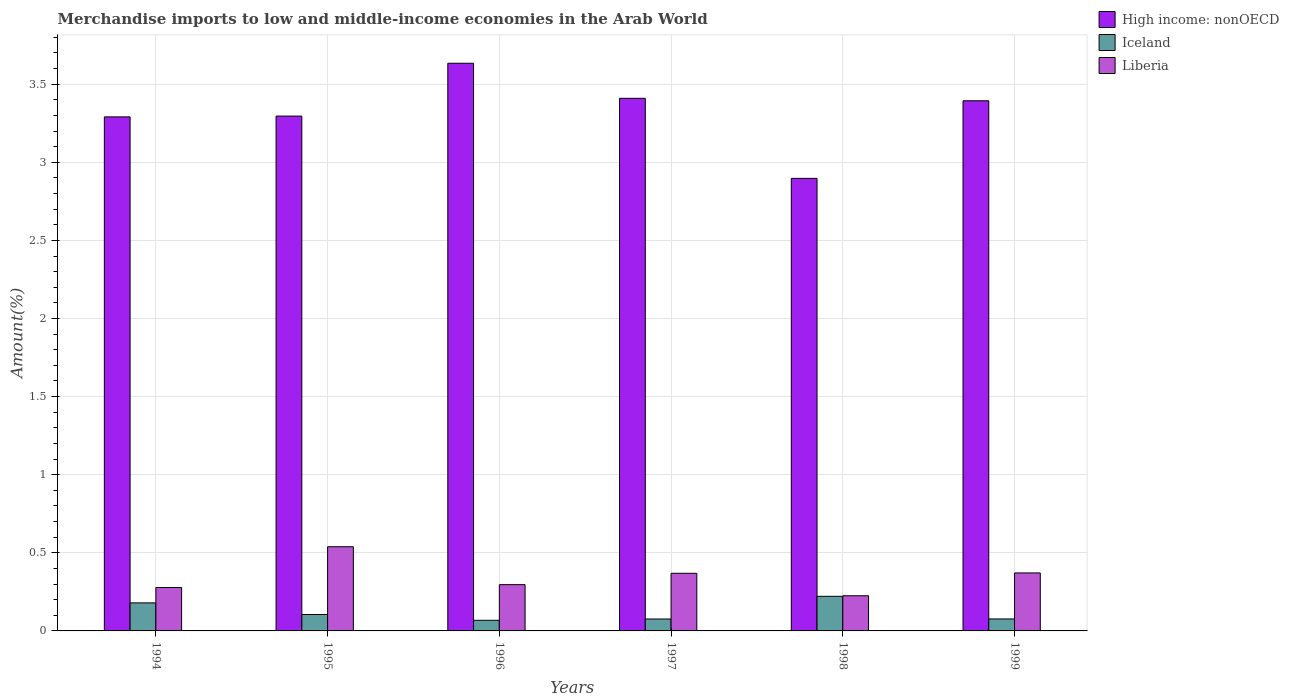How many different coloured bars are there?
Provide a short and direct response. 3. Are the number of bars per tick equal to the number of legend labels?
Provide a short and direct response. Yes. What is the label of the 6th group of bars from the left?
Provide a succinct answer. 1999. In how many cases, is the number of bars for a given year not equal to the number of legend labels?
Make the answer very short. 0. What is the percentage of amount earned from merchandise imports in Liberia in 1995?
Offer a very short reply. 0.54. Across all years, what is the maximum percentage of amount earned from merchandise imports in High income: nonOECD?
Give a very brief answer. 3.63. Across all years, what is the minimum percentage of amount earned from merchandise imports in Liberia?
Your answer should be very brief. 0.23. In which year was the percentage of amount earned from merchandise imports in High income: nonOECD minimum?
Keep it short and to the point. 1998. What is the total percentage of amount earned from merchandise imports in High income: nonOECD in the graph?
Keep it short and to the point. 19.92. What is the difference between the percentage of amount earned from merchandise imports in High income: nonOECD in 1995 and that in 1996?
Keep it short and to the point. -0.34. What is the difference between the percentage of amount earned from merchandise imports in Liberia in 1996 and the percentage of amount earned from merchandise imports in High income: nonOECD in 1994?
Offer a terse response. -2.99. What is the average percentage of amount earned from merchandise imports in High income: nonOECD per year?
Make the answer very short. 3.32. In the year 1999, what is the difference between the percentage of amount earned from merchandise imports in Iceland and percentage of amount earned from merchandise imports in High income: nonOECD?
Make the answer very short. -3.32. In how many years, is the percentage of amount earned from merchandise imports in Liberia greater than 1.4 %?
Offer a very short reply. 0. What is the ratio of the percentage of amount earned from merchandise imports in Liberia in 1994 to that in 1995?
Ensure brevity in your answer.  0.52. What is the difference between the highest and the second highest percentage of amount earned from merchandise imports in Iceland?
Keep it short and to the point. 0.04. What is the difference between the highest and the lowest percentage of amount earned from merchandise imports in High income: nonOECD?
Offer a terse response. 0.74. What does the 1st bar from the left in 1997 represents?
Offer a very short reply. High income: nonOECD. What does the 3rd bar from the right in 1999 represents?
Make the answer very short. High income: nonOECD. Is it the case that in every year, the sum of the percentage of amount earned from merchandise imports in Liberia and percentage of amount earned from merchandise imports in Iceland is greater than the percentage of amount earned from merchandise imports in High income: nonOECD?
Make the answer very short. No. How many bars are there?
Offer a very short reply. 18. Are all the bars in the graph horizontal?
Make the answer very short. No. How many years are there in the graph?
Provide a succinct answer. 6. Does the graph contain grids?
Give a very brief answer. Yes. How many legend labels are there?
Your answer should be compact. 3. What is the title of the graph?
Give a very brief answer. Merchandise imports to low and middle-income economies in the Arab World. What is the label or title of the X-axis?
Ensure brevity in your answer.  Years. What is the label or title of the Y-axis?
Offer a terse response. Amount(%). What is the Amount(%) in High income: nonOECD in 1994?
Make the answer very short. 3.29. What is the Amount(%) of Iceland in 1994?
Ensure brevity in your answer.  0.18. What is the Amount(%) of Liberia in 1994?
Provide a short and direct response. 0.28. What is the Amount(%) in High income: nonOECD in 1995?
Keep it short and to the point. 3.3. What is the Amount(%) of Iceland in 1995?
Provide a short and direct response. 0.11. What is the Amount(%) in Liberia in 1995?
Your answer should be very brief. 0.54. What is the Amount(%) in High income: nonOECD in 1996?
Offer a terse response. 3.63. What is the Amount(%) of Iceland in 1996?
Provide a short and direct response. 0.07. What is the Amount(%) in Liberia in 1996?
Ensure brevity in your answer.  0.3. What is the Amount(%) of High income: nonOECD in 1997?
Your response must be concise. 3.41. What is the Amount(%) in Iceland in 1997?
Offer a terse response. 0.08. What is the Amount(%) in Liberia in 1997?
Keep it short and to the point. 0.37. What is the Amount(%) in High income: nonOECD in 1998?
Offer a very short reply. 2.9. What is the Amount(%) in Iceland in 1998?
Make the answer very short. 0.22. What is the Amount(%) of Liberia in 1998?
Your response must be concise. 0.23. What is the Amount(%) of High income: nonOECD in 1999?
Provide a short and direct response. 3.39. What is the Amount(%) of Iceland in 1999?
Your answer should be compact. 0.08. What is the Amount(%) in Liberia in 1999?
Offer a very short reply. 0.37. Across all years, what is the maximum Amount(%) in High income: nonOECD?
Offer a very short reply. 3.63. Across all years, what is the maximum Amount(%) of Iceland?
Provide a short and direct response. 0.22. Across all years, what is the maximum Amount(%) in Liberia?
Make the answer very short. 0.54. Across all years, what is the minimum Amount(%) in High income: nonOECD?
Offer a terse response. 2.9. Across all years, what is the minimum Amount(%) of Iceland?
Provide a short and direct response. 0.07. Across all years, what is the minimum Amount(%) of Liberia?
Offer a very short reply. 0.23. What is the total Amount(%) in High income: nonOECD in the graph?
Ensure brevity in your answer.  19.92. What is the total Amount(%) of Iceland in the graph?
Keep it short and to the point. 0.73. What is the total Amount(%) of Liberia in the graph?
Provide a short and direct response. 2.08. What is the difference between the Amount(%) in High income: nonOECD in 1994 and that in 1995?
Ensure brevity in your answer.  -0.01. What is the difference between the Amount(%) in Iceland in 1994 and that in 1995?
Keep it short and to the point. 0.07. What is the difference between the Amount(%) of Liberia in 1994 and that in 1995?
Your answer should be compact. -0.26. What is the difference between the Amount(%) of High income: nonOECD in 1994 and that in 1996?
Make the answer very short. -0.34. What is the difference between the Amount(%) of Iceland in 1994 and that in 1996?
Offer a very short reply. 0.11. What is the difference between the Amount(%) of Liberia in 1994 and that in 1996?
Give a very brief answer. -0.02. What is the difference between the Amount(%) in High income: nonOECD in 1994 and that in 1997?
Your answer should be compact. -0.12. What is the difference between the Amount(%) of Iceland in 1994 and that in 1997?
Offer a terse response. 0.1. What is the difference between the Amount(%) of Liberia in 1994 and that in 1997?
Provide a short and direct response. -0.09. What is the difference between the Amount(%) of High income: nonOECD in 1994 and that in 1998?
Provide a succinct answer. 0.39. What is the difference between the Amount(%) in Iceland in 1994 and that in 1998?
Provide a succinct answer. -0.04. What is the difference between the Amount(%) of Liberia in 1994 and that in 1998?
Your answer should be very brief. 0.05. What is the difference between the Amount(%) in High income: nonOECD in 1994 and that in 1999?
Your answer should be compact. -0.1. What is the difference between the Amount(%) of Iceland in 1994 and that in 1999?
Offer a terse response. 0.1. What is the difference between the Amount(%) of Liberia in 1994 and that in 1999?
Your response must be concise. -0.09. What is the difference between the Amount(%) of High income: nonOECD in 1995 and that in 1996?
Make the answer very short. -0.34. What is the difference between the Amount(%) of Iceland in 1995 and that in 1996?
Provide a succinct answer. 0.04. What is the difference between the Amount(%) in Liberia in 1995 and that in 1996?
Your response must be concise. 0.24. What is the difference between the Amount(%) in High income: nonOECD in 1995 and that in 1997?
Ensure brevity in your answer.  -0.11. What is the difference between the Amount(%) in Iceland in 1995 and that in 1997?
Make the answer very short. 0.03. What is the difference between the Amount(%) of Liberia in 1995 and that in 1997?
Provide a succinct answer. 0.17. What is the difference between the Amount(%) of High income: nonOECD in 1995 and that in 1998?
Provide a succinct answer. 0.4. What is the difference between the Amount(%) of Iceland in 1995 and that in 1998?
Your answer should be very brief. -0.12. What is the difference between the Amount(%) of Liberia in 1995 and that in 1998?
Your answer should be very brief. 0.31. What is the difference between the Amount(%) of High income: nonOECD in 1995 and that in 1999?
Ensure brevity in your answer.  -0.1. What is the difference between the Amount(%) of Iceland in 1995 and that in 1999?
Your answer should be very brief. 0.03. What is the difference between the Amount(%) of Liberia in 1995 and that in 1999?
Provide a short and direct response. 0.17. What is the difference between the Amount(%) of High income: nonOECD in 1996 and that in 1997?
Offer a terse response. 0.22. What is the difference between the Amount(%) in Iceland in 1996 and that in 1997?
Your response must be concise. -0.01. What is the difference between the Amount(%) in Liberia in 1996 and that in 1997?
Your answer should be very brief. -0.07. What is the difference between the Amount(%) of High income: nonOECD in 1996 and that in 1998?
Offer a terse response. 0.74. What is the difference between the Amount(%) of Iceland in 1996 and that in 1998?
Give a very brief answer. -0.15. What is the difference between the Amount(%) of Liberia in 1996 and that in 1998?
Your answer should be very brief. 0.07. What is the difference between the Amount(%) of High income: nonOECD in 1996 and that in 1999?
Your response must be concise. 0.24. What is the difference between the Amount(%) of Iceland in 1996 and that in 1999?
Provide a short and direct response. -0.01. What is the difference between the Amount(%) in Liberia in 1996 and that in 1999?
Ensure brevity in your answer.  -0.08. What is the difference between the Amount(%) of High income: nonOECD in 1997 and that in 1998?
Your answer should be very brief. 0.51. What is the difference between the Amount(%) in Iceland in 1997 and that in 1998?
Make the answer very short. -0.15. What is the difference between the Amount(%) in Liberia in 1997 and that in 1998?
Your answer should be compact. 0.14. What is the difference between the Amount(%) in High income: nonOECD in 1997 and that in 1999?
Offer a very short reply. 0.02. What is the difference between the Amount(%) of Iceland in 1997 and that in 1999?
Your answer should be compact. -0. What is the difference between the Amount(%) in Liberia in 1997 and that in 1999?
Ensure brevity in your answer.  -0. What is the difference between the Amount(%) of High income: nonOECD in 1998 and that in 1999?
Offer a terse response. -0.5. What is the difference between the Amount(%) in Iceland in 1998 and that in 1999?
Your answer should be compact. 0.14. What is the difference between the Amount(%) in Liberia in 1998 and that in 1999?
Ensure brevity in your answer.  -0.15. What is the difference between the Amount(%) in High income: nonOECD in 1994 and the Amount(%) in Iceland in 1995?
Your answer should be compact. 3.19. What is the difference between the Amount(%) of High income: nonOECD in 1994 and the Amount(%) of Liberia in 1995?
Keep it short and to the point. 2.75. What is the difference between the Amount(%) in Iceland in 1994 and the Amount(%) in Liberia in 1995?
Your answer should be compact. -0.36. What is the difference between the Amount(%) of High income: nonOECD in 1994 and the Amount(%) of Iceland in 1996?
Offer a very short reply. 3.22. What is the difference between the Amount(%) of High income: nonOECD in 1994 and the Amount(%) of Liberia in 1996?
Make the answer very short. 2.99. What is the difference between the Amount(%) of Iceland in 1994 and the Amount(%) of Liberia in 1996?
Provide a succinct answer. -0.12. What is the difference between the Amount(%) in High income: nonOECD in 1994 and the Amount(%) in Iceland in 1997?
Provide a short and direct response. 3.21. What is the difference between the Amount(%) in High income: nonOECD in 1994 and the Amount(%) in Liberia in 1997?
Ensure brevity in your answer.  2.92. What is the difference between the Amount(%) in Iceland in 1994 and the Amount(%) in Liberia in 1997?
Ensure brevity in your answer.  -0.19. What is the difference between the Amount(%) of High income: nonOECD in 1994 and the Amount(%) of Iceland in 1998?
Ensure brevity in your answer.  3.07. What is the difference between the Amount(%) of High income: nonOECD in 1994 and the Amount(%) of Liberia in 1998?
Give a very brief answer. 3.07. What is the difference between the Amount(%) in Iceland in 1994 and the Amount(%) in Liberia in 1998?
Your response must be concise. -0.05. What is the difference between the Amount(%) in High income: nonOECD in 1994 and the Amount(%) in Iceland in 1999?
Ensure brevity in your answer.  3.21. What is the difference between the Amount(%) in High income: nonOECD in 1994 and the Amount(%) in Liberia in 1999?
Keep it short and to the point. 2.92. What is the difference between the Amount(%) of Iceland in 1994 and the Amount(%) of Liberia in 1999?
Keep it short and to the point. -0.19. What is the difference between the Amount(%) in High income: nonOECD in 1995 and the Amount(%) in Iceland in 1996?
Give a very brief answer. 3.23. What is the difference between the Amount(%) in High income: nonOECD in 1995 and the Amount(%) in Liberia in 1996?
Your response must be concise. 3. What is the difference between the Amount(%) in Iceland in 1995 and the Amount(%) in Liberia in 1996?
Make the answer very short. -0.19. What is the difference between the Amount(%) of High income: nonOECD in 1995 and the Amount(%) of Iceland in 1997?
Give a very brief answer. 3.22. What is the difference between the Amount(%) in High income: nonOECD in 1995 and the Amount(%) in Liberia in 1997?
Ensure brevity in your answer.  2.93. What is the difference between the Amount(%) of Iceland in 1995 and the Amount(%) of Liberia in 1997?
Keep it short and to the point. -0.26. What is the difference between the Amount(%) in High income: nonOECD in 1995 and the Amount(%) in Iceland in 1998?
Your answer should be compact. 3.07. What is the difference between the Amount(%) of High income: nonOECD in 1995 and the Amount(%) of Liberia in 1998?
Give a very brief answer. 3.07. What is the difference between the Amount(%) of Iceland in 1995 and the Amount(%) of Liberia in 1998?
Your answer should be very brief. -0.12. What is the difference between the Amount(%) of High income: nonOECD in 1995 and the Amount(%) of Iceland in 1999?
Provide a short and direct response. 3.22. What is the difference between the Amount(%) of High income: nonOECD in 1995 and the Amount(%) of Liberia in 1999?
Ensure brevity in your answer.  2.92. What is the difference between the Amount(%) of Iceland in 1995 and the Amount(%) of Liberia in 1999?
Make the answer very short. -0.27. What is the difference between the Amount(%) in High income: nonOECD in 1996 and the Amount(%) in Iceland in 1997?
Provide a succinct answer. 3.56. What is the difference between the Amount(%) in High income: nonOECD in 1996 and the Amount(%) in Liberia in 1997?
Ensure brevity in your answer.  3.27. What is the difference between the Amount(%) in Iceland in 1996 and the Amount(%) in Liberia in 1997?
Offer a very short reply. -0.3. What is the difference between the Amount(%) of High income: nonOECD in 1996 and the Amount(%) of Iceland in 1998?
Provide a short and direct response. 3.41. What is the difference between the Amount(%) of High income: nonOECD in 1996 and the Amount(%) of Liberia in 1998?
Offer a very short reply. 3.41. What is the difference between the Amount(%) in Iceland in 1996 and the Amount(%) in Liberia in 1998?
Ensure brevity in your answer.  -0.16. What is the difference between the Amount(%) in High income: nonOECD in 1996 and the Amount(%) in Iceland in 1999?
Provide a succinct answer. 3.56. What is the difference between the Amount(%) of High income: nonOECD in 1996 and the Amount(%) of Liberia in 1999?
Your answer should be compact. 3.26. What is the difference between the Amount(%) of Iceland in 1996 and the Amount(%) of Liberia in 1999?
Make the answer very short. -0.3. What is the difference between the Amount(%) in High income: nonOECD in 1997 and the Amount(%) in Iceland in 1998?
Make the answer very short. 3.19. What is the difference between the Amount(%) of High income: nonOECD in 1997 and the Amount(%) of Liberia in 1998?
Provide a succinct answer. 3.18. What is the difference between the Amount(%) of Iceland in 1997 and the Amount(%) of Liberia in 1998?
Your answer should be very brief. -0.15. What is the difference between the Amount(%) in High income: nonOECD in 1997 and the Amount(%) in Iceland in 1999?
Provide a succinct answer. 3.33. What is the difference between the Amount(%) in High income: nonOECD in 1997 and the Amount(%) in Liberia in 1999?
Make the answer very short. 3.04. What is the difference between the Amount(%) of Iceland in 1997 and the Amount(%) of Liberia in 1999?
Offer a very short reply. -0.29. What is the difference between the Amount(%) of High income: nonOECD in 1998 and the Amount(%) of Iceland in 1999?
Give a very brief answer. 2.82. What is the difference between the Amount(%) of High income: nonOECD in 1998 and the Amount(%) of Liberia in 1999?
Your response must be concise. 2.53. What is the difference between the Amount(%) of Iceland in 1998 and the Amount(%) of Liberia in 1999?
Your answer should be compact. -0.15. What is the average Amount(%) in High income: nonOECD per year?
Provide a succinct answer. 3.32. What is the average Amount(%) of Iceland per year?
Provide a short and direct response. 0.12. What is the average Amount(%) of Liberia per year?
Keep it short and to the point. 0.35. In the year 1994, what is the difference between the Amount(%) in High income: nonOECD and Amount(%) in Iceland?
Give a very brief answer. 3.11. In the year 1994, what is the difference between the Amount(%) of High income: nonOECD and Amount(%) of Liberia?
Your response must be concise. 3.01. In the year 1994, what is the difference between the Amount(%) of Iceland and Amount(%) of Liberia?
Provide a short and direct response. -0.1. In the year 1995, what is the difference between the Amount(%) in High income: nonOECD and Amount(%) in Iceland?
Make the answer very short. 3.19. In the year 1995, what is the difference between the Amount(%) in High income: nonOECD and Amount(%) in Liberia?
Provide a succinct answer. 2.76. In the year 1995, what is the difference between the Amount(%) of Iceland and Amount(%) of Liberia?
Ensure brevity in your answer.  -0.43. In the year 1996, what is the difference between the Amount(%) of High income: nonOECD and Amount(%) of Iceland?
Your answer should be compact. 3.57. In the year 1996, what is the difference between the Amount(%) of High income: nonOECD and Amount(%) of Liberia?
Make the answer very short. 3.34. In the year 1996, what is the difference between the Amount(%) of Iceland and Amount(%) of Liberia?
Make the answer very short. -0.23. In the year 1997, what is the difference between the Amount(%) in High income: nonOECD and Amount(%) in Iceland?
Your answer should be compact. 3.33. In the year 1997, what is the difference between the Amount(%) in High income: nonOECD and Amount(%) in Liberia?
Your answer should be very brief. 3.04. In the year 1997, what is the difference between the Amount(%) of Iceland and Amount(%) of Liberia?
Ensure brevity in your answer.  -0.29. In the year 1998, what is the difference between the Amount(%) in High income: nonOECD and Amount(%) in Iceland?
Your answer should be compact. 2.68. In the year 1998, what is the difference between the Amount(%) in High income: nonOECD and Amount(%) in Liberia?
Provide a succinct answer. 2.67. In the year 1998, what is the difference between the Amount(%) in Iceland and Amount(%) in Liberia?
Offer a very short reply. -0. In the year 1999, what is the difference between the Amount(%) of High income: nonOECD and Amount(%) of Iceland?
Ensure brevity in your answer.  3.32. In the year 1999, what is the difference between the Amount(%) of High income: nonOECD and Amount(%) of Liberia?
Offer a terse response. 3.02. In the year 1999, what is the difference between the Amount(%) in Iceland and Amount(%) in Liberia?
Provide a short and direct response. -0.29. What is the ratio of the Amount(%) of High income: nonOECD in 1994 to that in 1995?
Provide a short and direct response. 1. What is the ratio of the Amount(%) in Iceland in 1994 to that in 1995?
Ensure brevity in your answer.  1.71. What is the ratio of the Amount(%) in Liberia in 1994 to that in 1995?
Give a very brief answer. 0.52. What is the ratio of the Amount(%) in High income: nonOECD in 1994 to that in 1996?
Your answer should be compact. 0.91. What is the ratio of the Amount(%) of Iceland in 1994 to that in 1996?
Give a very brief answer. 2.64. What is the ratio of the Amount(%) in Liberia in 1994 to that in 1996?
Your answer should be compact. 0.94. What is the ratio of the Amount(%) in High income: nonOECD in 1994 to that in 1997?
Make the answer very short. 0.97. What is the ratio of the Amount(%) of Iceland in 1994 to that in 1997?
Your answer should be very brief. 2.35. What is the ratio of the Amount(%) of Liberia in 1994 to that in 1997?
Keep it short and to the point. 0.75. What is the ratio of the Amount(%) in High income: nonOECD in 1994 to that in 1998?
Offer a very short reply. 1.14. What is the ratio of the Amount(%) in Iceland in 1994 to that in 1998?
Provide a short and direct response. 0.81. What is the ratio of the Amount(%) of Liberia in 1994 to that in 1998?
Your answer should be compact. 1.23. What is the ratio of the Amount(%) of High income: nonOECD in 1994 to that in 1999?
Keep it short and to the point. 0.97. What is the ratio of the Amount(%) in Iceland in 1994 to that in 1999?
Ensure brevity in your answer.  2.34. What is the ratio of the Amount(%) in Liberia in 1994 to that in 1999?
Provide a succinct answer. 0.75. What is the ratio of the Amount(%) of High income: nonOECD in 1995 to that in 1996?
Your answer should be very brief. 0.91. What is the ratio of the Amount(%) in Iceland in 1995 to that in 1996?
Offer a terse response. 1.54. What is the ratio of the Amount(%) in Liberia in 1995 to that in 1996?
Your answer should be very brief. 1.82. What is the ratio of the Amount(%) in High income: nonOECD in 1995 to that in 1997?
Provide a succinct answer. 0.97. What is the ratio of the Amount(%) of Iceland in 1995 to that in 1997?
Give a very brief answer. 1.38. What is the ratio of the Amount(%) of Liberia in 1995 to that in 1997?
Give a very brief answer. 1.46. What is the ratio of the Amount(%) of High income: nonOECD in 1995 to that in 1998?
Your answer should be very brief. 1.14. What is the ratio of the Amount(%) of Iceland in 1995 to that in 1998?
Keep it short and to the point. 0.47. What is the ratio of the Amount(%) of Liberia in 1995 to that in 1998?
Ensure brevity in your answer.  2.39. What is the ratio of the Amount(%) of High income: nonOECD in 1995 to that in 1999?
Ensure brevity in your answer.  0.97. What is the ratio of the Amount(%) in Iceland in 1995 to that in 1999?
Provide a succinct answer. 1.37. What is the ratio of the Amount(%) in Liberia in 1995 to that in 1999?
Give a very brief answer. 1.45. What is the ratio of the Amount(%) in High income: nonOECD in 1996 to that in 1997?
Your answer should be compact. 1.07. What is the ratio of the Amount(%) of Iceland in 1996 to that in 1997?
Provide a succinct answer. 0.89. What is the ratio of the Amount(%) of Liberia in 1996 to that in 1997?
Your response must be concise. 0.8. What is the ratio of the Amount(%) of High income: nonOECD in 1996 to that in 1998?
Your answer should be very brief. 1.25. What is the ratio of the Amount(%) of Iceland in 1996 to that in 1998?
Give a very brief answer. 0.31. What is the ratio of the Amount(%) in Liberia in 1996 to that in 1998?
Ensure brevity in your answer.  1.32. What is the ratio of the Amount(%) in High income: nonOECD in 1996 to that in 1999?
Provide a short and direct response. 1.07. What is the ratio of the Amount(%) of Iceland in 1996 to that in 1999?
Your response must be concise. 0.89. What is the ratio of the Amount(%) in Liberia in 1996 to that in 1999?
Your answer should be compact. 0.8. What is the ratio of the Amount(%) of High income: nonOECD in 1997 to that in 1998?
Keep it short and to the point. 1.18. What is the ratio of the Amount(%) of Iceland in 1997 to that in 1998?
Your answer should be very brief. 0.34. What is the ratio of the Amount(%) in Liberia in 1997 to that in 1998?
Give a very brief answer. 1.64. What is the ratio of the Amount(%) of High income: nonOECD in 1997 to that in 1999?
Make the answer very short. 1. What is the ratio of the Amount(%) of Liberia in 1997 to that in 1999?
Give a very brief answer. 0.99. What is the ratio of the Amount(%) of High income: nonOECD in 1998 to that in 1999?
Your answer should be very brief. 0.85. What is the ratio of the Amount(%) in Iceland in 1998 to that in 1999?
Offer a terse response. 2.89. What is the ratio of the Amount(%) in Liberia in 1998 to that in 1999?
Your answer should be compact. 0.61. What is the difference between the highest and the second highest Amount(%) of High income: nonOECD?
Provide a short and direct response. 0.22. What is the difference between the highest and the second highest Amount(%) of Iceland?
Ensure brevity in your answer.  0.04. What is the difference between the highest and the second highest Amount(%) in Liberia?
Provide a short and direct response. 0.17. What is the difference between the highest and the lowest Amount(%) of High income: nonOECD?
Your answer should be compact. 0.74. What is the difference between the highest and the lowest Amount(%) of Iceland?
Your response must be concise. 0.15. What is the difference between the highest and the lowest Amount(%) of Liberia?
Make the answer very short. 0.31. 